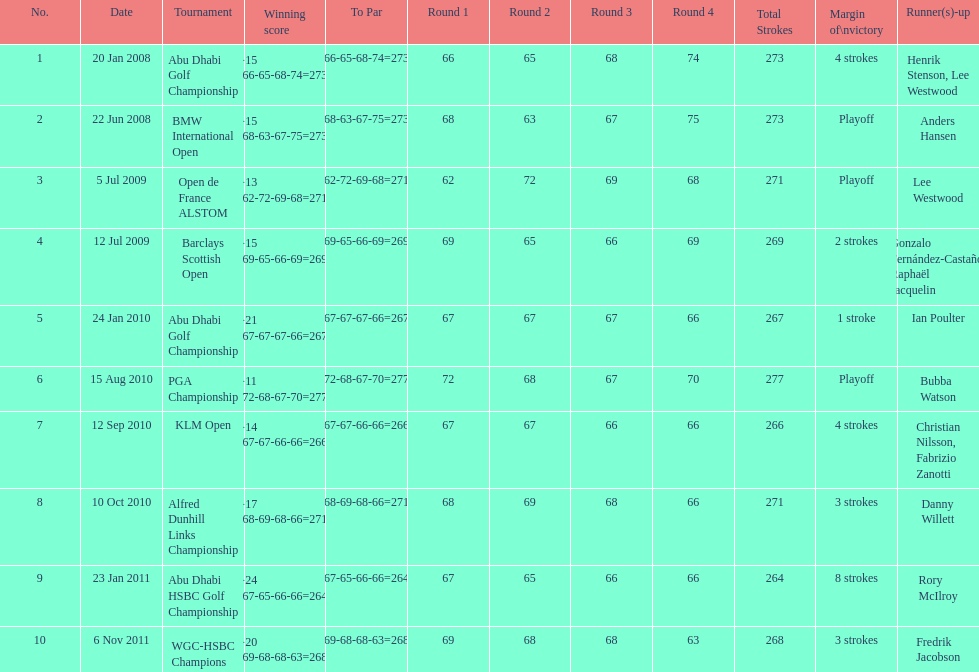Can you parse all the data within this table? {'header': ['No.', 'Date', 'Tournament', 'Winning score', 'To Par', 'Round 1', 'Round 2', 'Round 3', 'Round 4', 'Total Strokes', 'Margin of\\nvictory', 'Runner(s)-up'], 'rows': [['1', '20 Jan 2008', 'Abu Dhabi Golf Championship', '−15 (66-65-68-74=273)', '(66-65-68-74=273)', '66', '65', '68', '74', '273', '4 strokes', 'Henrik Stenson, Lee Westwood'], ['2', '22 Jun 2008', 'BMW International Open', '−15 (68-63-67-75=273)', '(68-63-67-75=273)', '68', '63', '67', '75', '273', 'Playoff', 'Anders Hansen'], ['3', '5 Jul 2009', 'Open de France ALSTOM', '−13 (62-72-69-68=271)', '(62-72-69-68=271)', '62', '72', '69', '68', '271', 'Playoff', 'Lee Westwood'], ['4', '12 Jul 2009', 'Barclays Scottish Open', '−15 (69-65-66-69=269)', '(69-65-66-69=269)', '69', '65', '66', '69', '269', '2 strokes', 'Gonzalo Fernández-Castaño, Raphaël Jacquelin'], ['5', '24 Jan 2010', 'Abu Dhabi Golf Championship', '−21 (67-67-67-66=267)', '(67-67-67-66=267)', '67', '67', '67', '66', '267', '1 stroke', 'Ian Poulter'], ['6', '15 Aug 2010', 'PGA Championship', '−11 (72-68-67-70=277)', '(72-68-67-70=277)', '72', '68', '67', '70', '277', 'Playoff', 'Bubba Watson'], ['7', '12 Sep 2010', 'KLM Open', '−14 (67-67-66-66=266)', '(67-67-66-66=266)', '67', '67', '66', '66', '266', '4 strokes', 'Christian Nilsson, Fabrizio Zanotti'], ['8', '10 Oct 2010', 'Alfred Dunhill Links Championship', '−17 (68-69-68-66=271)', '(68-69-68-66=271)', '68', '69', '68', '66', '271', '3 strokes', 'Danny Willett'], ['9', '23 Jan 2011', 'Abu Dhabi HSBC Golf Championship', '−24 (67-65-66-66=264)', '(67-65-66-66=264)', '67', '65', '66', '66', '264', '8 strokes', 'Rory McIlroy'], ['10', '6 Nov 2011', 'WGC-HSBC Champions', '−20 (69-68-68-63=268)', '(69-68-68-63=268)', '69', '68', '68', '63', '268', '3 strokes', 'Fredrik Jacobson']]} How long separated the playoff victory at bmw international open and the 4 stroke victory at the klm open? 2 years. 